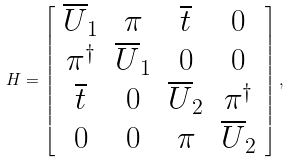Convert formula to latex. <formula><loc_0><loc_0><loc_500><loc_500>H = \left [ \begin{array} { c c c c } \overline { U } _ { 1 } & \pi & \overline { t } & 0 \\ \pi ^ { \dag } & \overline { U } _ { 1 } & 0 & 0 \\ \overline { t } & 0 & \overline { U } _ { 2 } & \pi ^ { \dag } \\ 0 & 0 & \pi & \overline { U } _ { 2 } \end{array} \right ] ,</formula> 